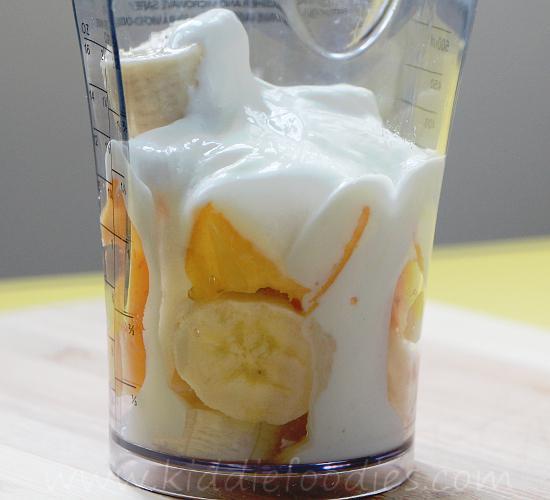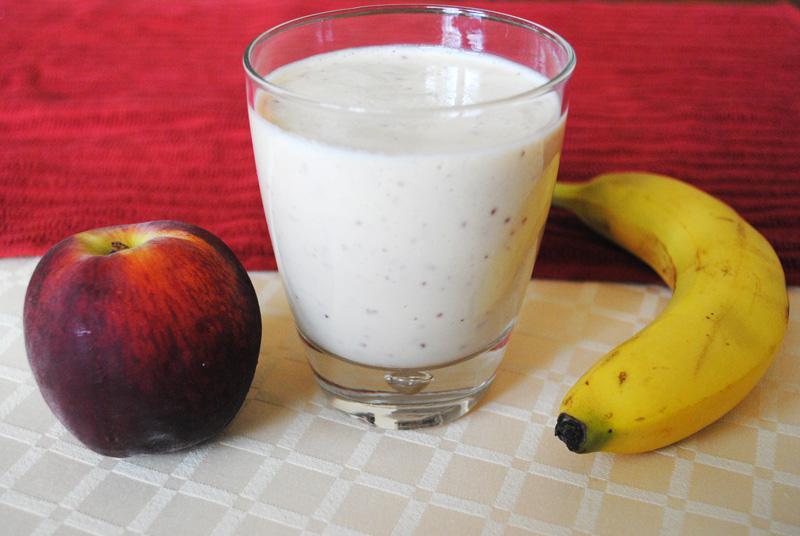The first image is the image on the left, the second image is the image on the right. Considering the images on both sides, is "There is a full white cup with one whole banana and apple on either side of it." valid? Answer yes or no. Yes. The first image is the image on the left, the second image is the image on the right. Given the left and right images, does the statement "There is whole uncut fruit in the right image." hold true? Answer yes or no. Yes. 